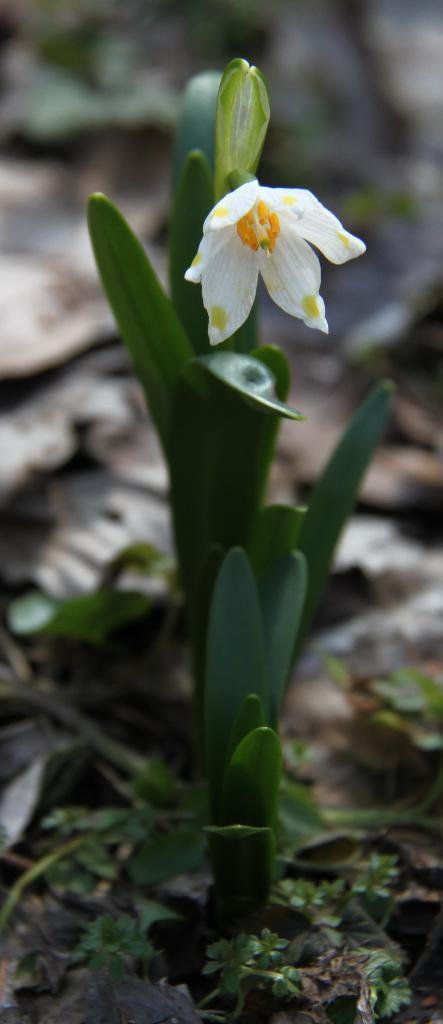What type of plant is featured in the image? There is a plant with a white flower in the image. What color is predominant in the background of the image? The background of the image is green. What color is present at the bottom of the image? The bottom of the image also has green color. What type of tail can be seen on the plant in the image? There is no tail present on the plant in the image. What experience does the plant have with growing in different environments? The image does not provide any information about the plant's experience with growing in different environments. 